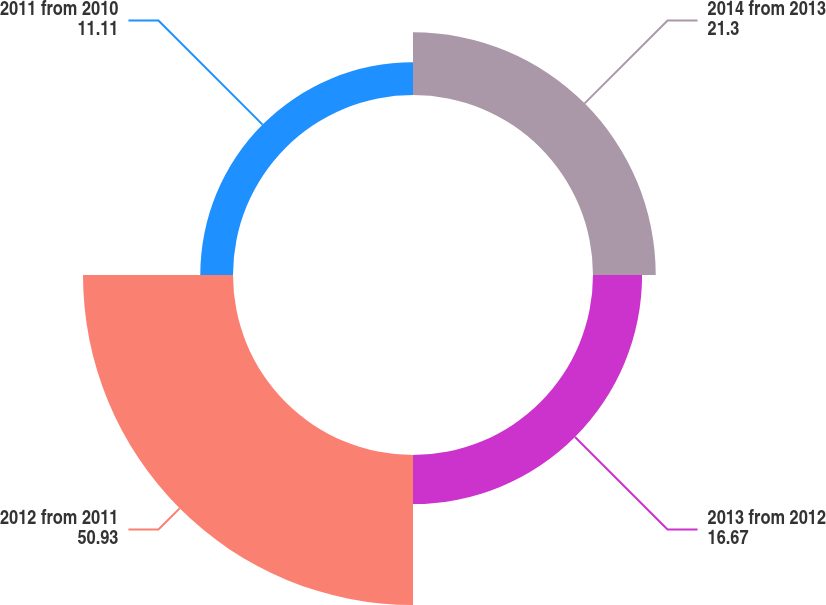<chart> <loc_0><loc_0><loc_500><loc_500><pie_chart><fcel>2014 from 2013<fcel>2013 from 2012<fcel>2012 from 2011<fcel>2011 from 2010<nl><fcel>21.3%<fcel>16.67%<fcel>50.93%<fcel>11.11%<nl></chart> 